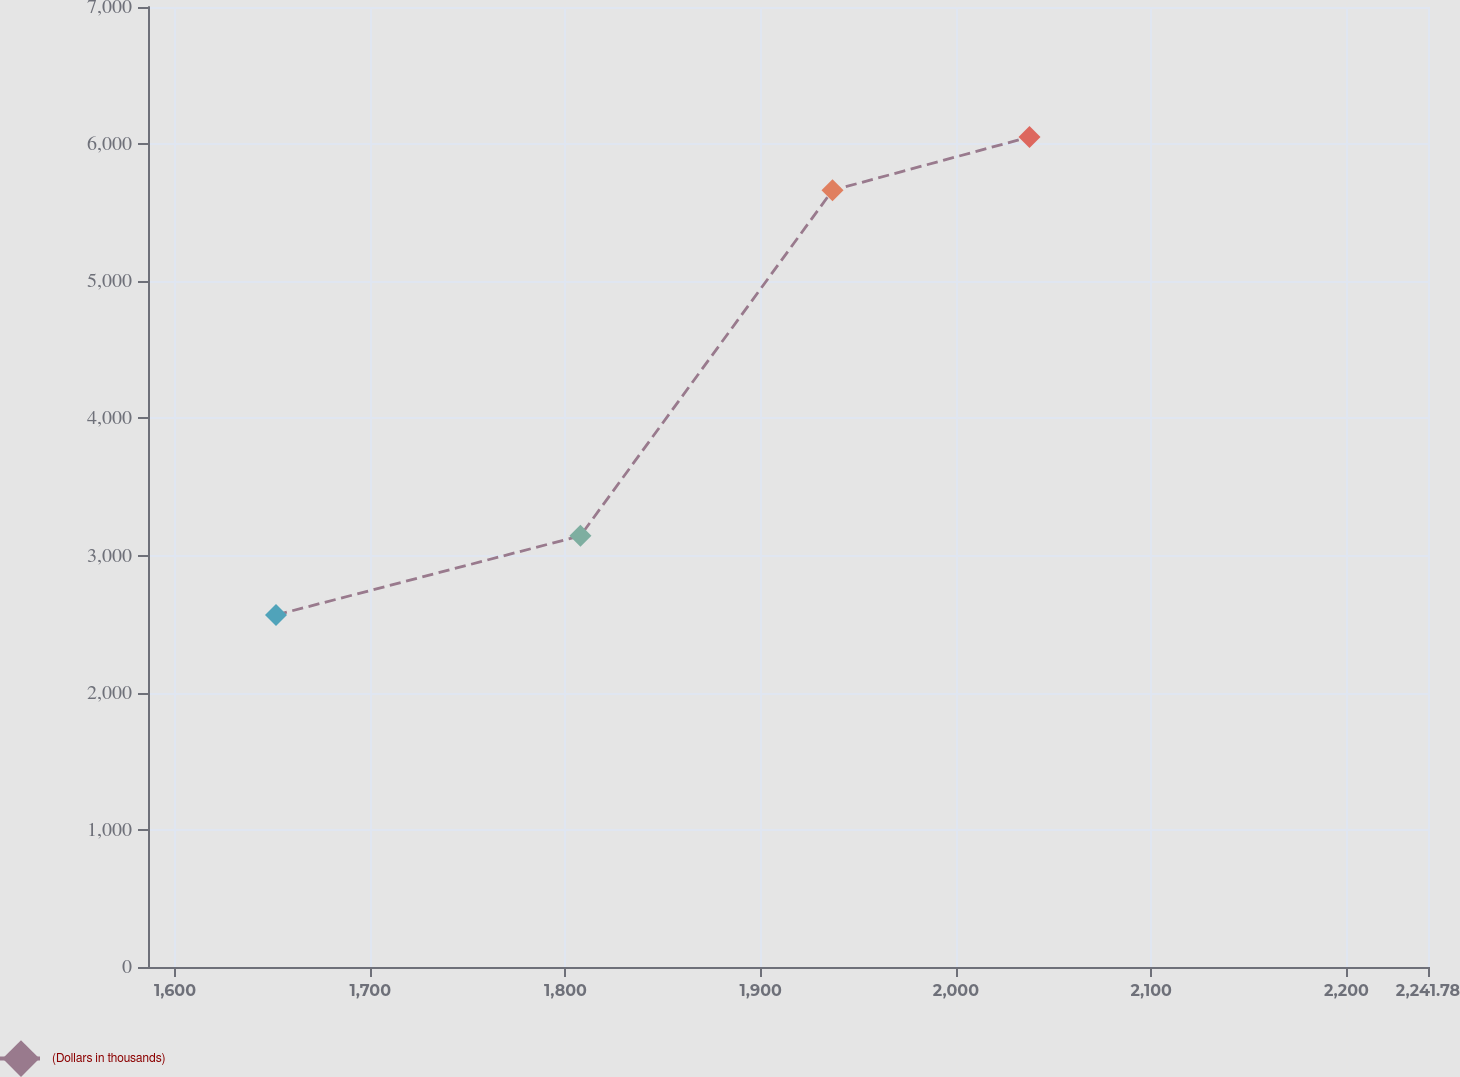Convert chart to OTSL. <chart><loc_0><loc_0><loc_500><loc_500><line_chart><ecel><fcel>(Dollars in thousands)<nl><fcel>1651.74<fcel>2566.7<nl><fcel>1807.66<fcel>3144.15<nl><fcel>1936.78<fcel>5663.55<nl><fcel>2037.67<fcel>6052.14<nl><fcel>2307.34<fcel>6452.57<nl></chart> 